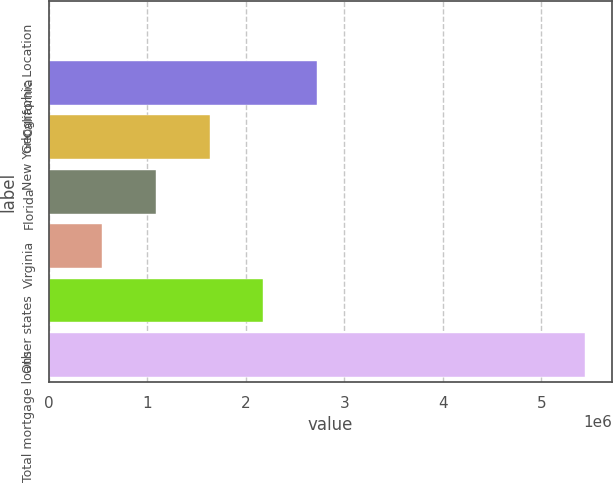Convert chart. <chart><loc_0><loc_0><loc_500><loc_500><bar_chart><fcel>Geographic Location<fcel>California<fcel>New York<fcel>Florida<fcel>Virginia<fcel>Other states<fcel>Total mortgage loans<nl><fcel>2012<fcel>2.72209e+06<fcel>1.63406e+06<fcel>1.09004e+06<fcel>546028<fcel>2.17808e+06<fcel>5.44217e+06<nl></chart> 